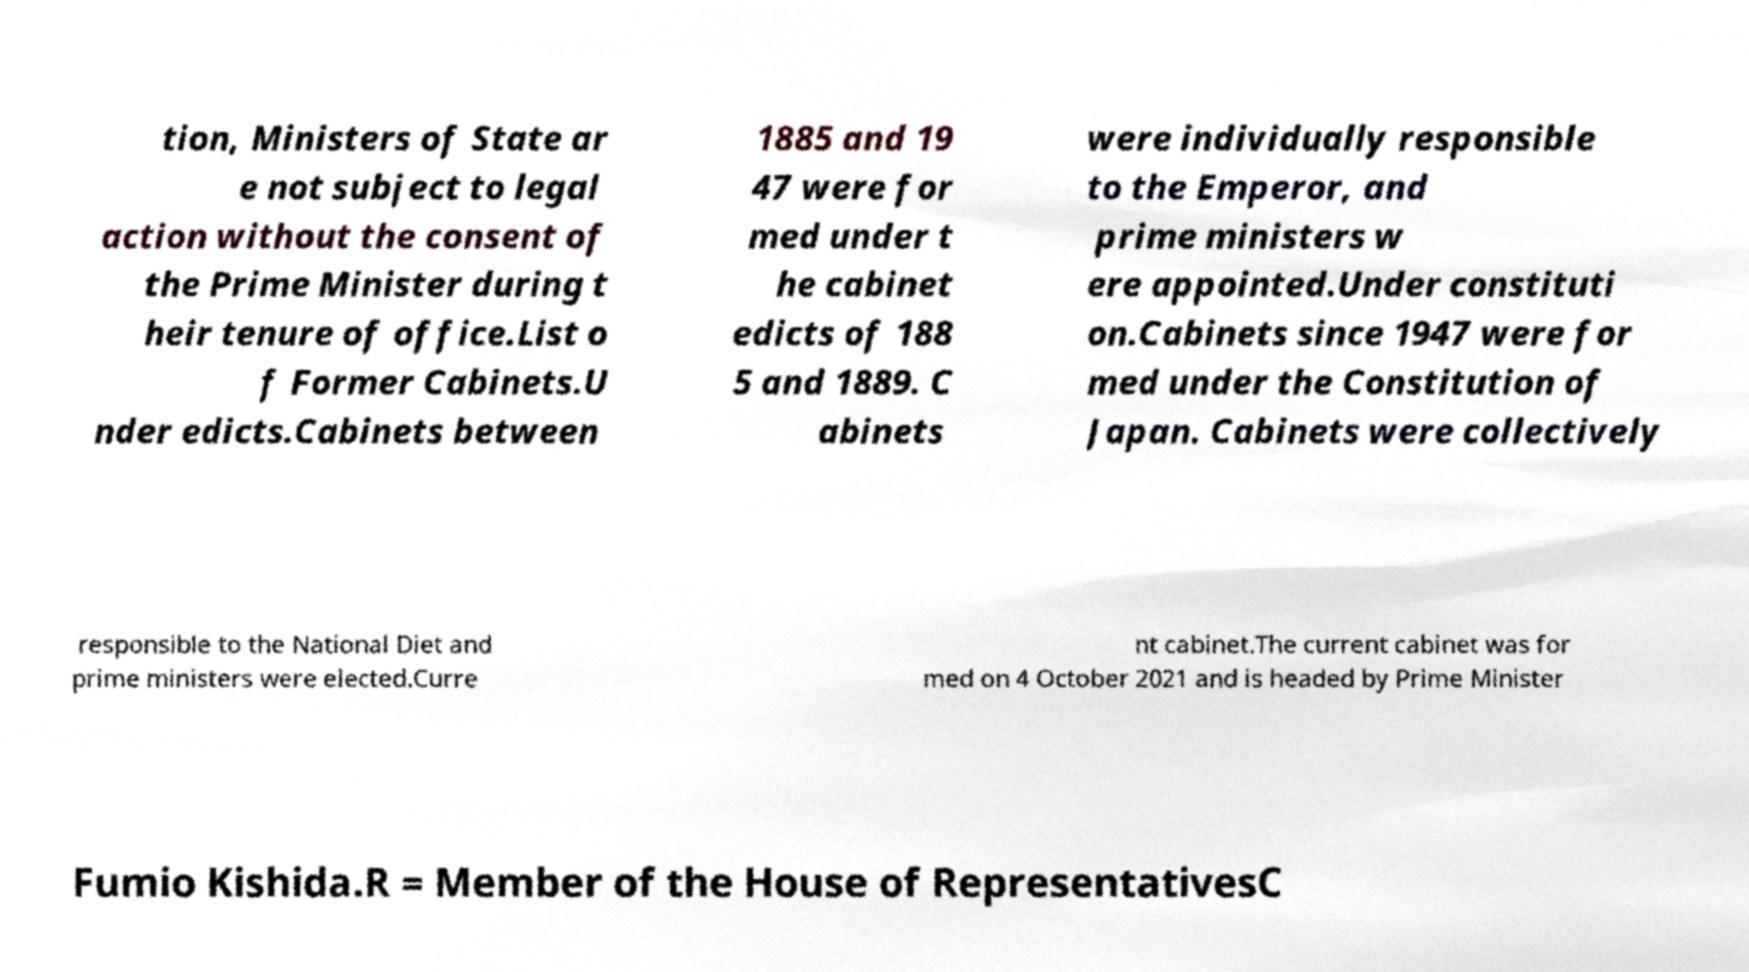Please read and relay the text visible in this image. What does it say? tion, Ministers of State ar e not subject to legal action without the consent of the Prime Minister during t heir tenure of office.List o f Former Cabinets.U nder edicts.Cabinets between 1885 and 19 47 were for med under t he cabinet edicts of 188 5 and 1889. C abinets were individually responsible to the Emperor, and prime ministers w ere appointed.Under constituti on.Cabinets since 1947 were for med under the Constitution of Japan. Cabinets were collectively responsible to the National Diet and prime ministers were elected.Curre nt cabinet.The current cabinet was for med on 4 October 2021 and is headed by Prime Minister Fumio Kishida.R = Member of the House of RepresentativesC 